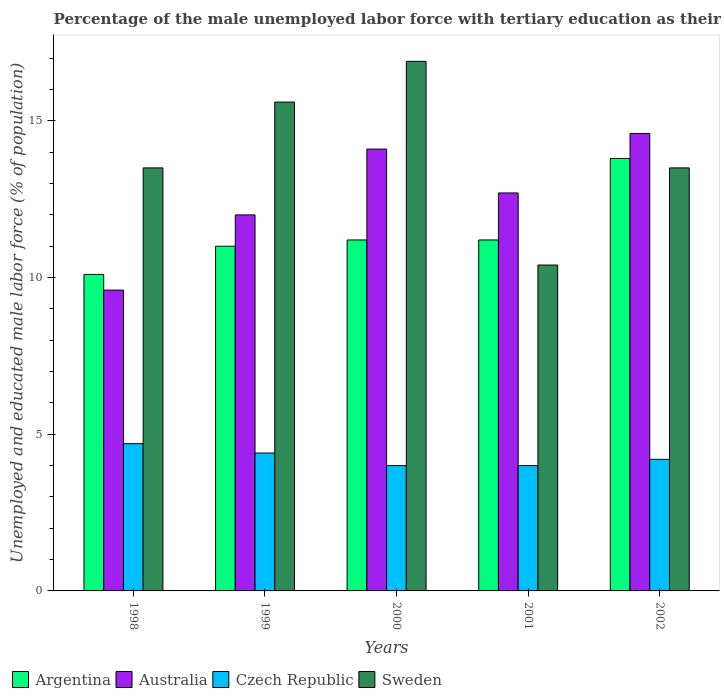How many different coloured bars are there?
Your response must be concise. 4. How many groups of bars are there?
Provide a short and direct response. 5. Are the number of bars per tick equal to the number of legend labels?
Offer a very short reply. Yes. Are the number of bars on each tick of the X-axis equal?
Offer a terse response. Yes. How many bars are there on the 1st tick from the right?
Provide a short and direct response. 4. What is the label of the 5th group of bars from the left?
Your answer should be very brief. 2002. What is the percentage of the unemployed male labor force with tertiary education in Argentina in 2002?
Keep it short and to the point. 13.8. Across all years, what is the maximum percentage of the unemployed male labor force with tertiary education in Australia?
Your response must be concise. 14.6. Across all years, what is the minimum percentage of the unemployed male labor force with tertiary education in Czech Republic?
Your response must be concise. 4. In which year was the percentage of the unemployed male labor force with tertiary education in Australia maximum?
Ensure brevity in your answer.  2002. What is the total percentage of the unemployed male labor force with tertiary education in Czech Republic in the graph?
Offer a terse response. 21.3. What is the difference between the percentage of the unemployed male labor force with tertiary education in Australia in 1998 and that in 2002?
Provide a succinct answer. -5. What is the difference between the percentage of the unemployed male labor force with tertiary education in Argentina in 2001 and the percentage of the unemployed male labor force with tertiary education in Australia in 1999?
Offer a very short reply. -0.8. What is the average percentage of the unemployed male labor force with tertiary education in Argentina per year?
Your answer should be very brief. 11.46. In the year 2002, what is the difference between the percentage of the unemployed male labor force with tertiary education in Czech Republic and percentage of the unemployed male labor force with tertiary education in Sweden?
Give a very brief answer. -9.3. In how many years, is the percentage of the unemployed male labor force with tertiary education in Sweden greater than 5 %?
Keep it short and to the point. 5. What is the ratio of the percentage of the unemployed male labor force with tertiary education in Czech Republic in 1999 to that in 2002?
Offer a very short reply. 1.05. Is the percentage of the unemployed male labor force with tertiary education in Czech Republic in 1998 less than that in 1999?
Provide a succinct answer. No. Is the difference between the percentage of the unemployed male labor force with tertiary education in Czech Republic in 2000 and 2001 greater than the difference between the percentage of the unemployed male labor force with tertiary education in Sweden in 2000 and 2001?
Offer a terse response. No. What is the difference between the highest and the second highest percentage of the unemployed male labor force with tertiary education in Czech Republic?
Your response must be concise. 0.3. What is the difference between the highest and the lowest percentage of the unemployed male labor force with tertiary education in Australia?
Give a very brief answer. 5. In how many years, is the percentage of the unemployed male labor force with tertiary education in Australia greater than the average percentage of the unemployed male labor force with tertiary education in Australia taken over all years?
Your answer should be very brief. 3. What does the 3rd bar from the left in 2002 represents?
Your response must be concise. Czech Republic. Is it the case that in every year, the sum of the percentage of the unemployed male labor force with tertiary education in Czech Republic and percentage of the unemployed male labor force with tertiary education in Sweden is greater than the percentage of the unemployed male labor force with tertiary education in Argentina?
Make the answer very short. Yes. How many bars are there?
Your answer should be very brief. 20. How many years are there in the graph?
Your answer should be compact. 5. Are the values on the major ticks of Y-axis written in scientific E-notation?
Ensure brevity in your answer.  No. Does the graph contain any zero values?
Your answer should be compact. No. Where does the legend appear in the graph?
Offer a terse response. Bottom left. What is the title of the graph?
Offer a very short reply. Percentage of the male unemployed labor force with tertiary education as their highest grade. Does "St. Lucia" appear as one of the legend labels in the graph?
Give a very brief answer. No. What is the label or title of the Y-axis?
Your response must be concise. Unemployed and educated male labor force (% of population). What is the Unemployed and educated male labor force (% of population) of Argentina in 1998?
Offer a very short reply. 10.1. What is the Unemployed and educated male labor force (% of population) in Australia in 1998?
Offer a very short reply. 9.6. What is the Unemployed and educated male labor force (% of population) of Czech Republic in 1998?
Ensure brevity in your answer.  4.7. What is the Unemployed and educated male labor force (% of population) of Sweden in 1998?
Ensure brevity in your answer.  13.5. What is the Unemployed and educated male labor force (% of population) of Argentina in 1999?
Your response must be concise. 11. What is the Unemployed and educated male labor force (% of population) of Australia in 1999?
Keep it short and to the point. 12. What is the Unemployed and educated male labor force (% of population) of Czech Republic in 1999?
Make the answer very short. 4.4. What is the Unemployed and educated male labor force (% of population) of Sweden in 1999?
Ensure brevity in your answer.  15.6. What is the Unemployed and educated male labor force (% of population) of Argentina in 2000?
Give a very brief answer. 11.2. What is the Unemployed and educated male labor force (% of population) in Australia in 2000?
Offer a terse response. 14.1. What is the Unemployed and educated male labor force (% of population) in Czech Republic in 2000?
Your response must be concise. 4. What is the Unemployed and educated male labor force (% of population) of Sweden in 2000?
Your answer should be very brief. 16.9. What is the Unemployed and educated male labor force (% of population) in Argentina in 2001?
Provide a succinct answer. 11.2. What is the Unemployed and educated male labor force (% of population) of Australia in 2001?
Ensure brevity in your answer.  12.7. What is the Unemployed and educated male labor force (% of population) of Czech Republic in 2001?
Your response must be concise. 4. What is the Unemployed and educated male labor force (% of population) in Sweden in 2001?
Your answer should be very brief. 10.4. What is the Unemployed and educated male labor force (% of population) in Argentina in 2002?
Provide a short and direct response. 13.8. What is the Unemployed and educated male labor force (% of population) in Australia in 2002?
Give a very brief answer. 14.6. What is the Unemployed and educated male labor force (% of population) in Czech Republic in 2002?
Give a very brief answer. 4.2. What is the Unemployed and educated male labor force (% of population) in Sweden in 2002?
Offer a very short reply. 13.5. Across all years, what is the maximum Unemployed and educated male labor force (% of population) in Argentina?
Provide a succinct answer. 13.8. Across all years, what is the maximum Unemployed and educated male labor force (% of population) of Australia?
Offer a terse response. 14.6. Across all years, what is the maximum Unemployed and educated male labor force (% of population) of Czech Republic?
Keep it short and to the point. 4.7. Across all years, what is the maximum Unemployed and educated male labor force (% of population) in Sweden?
Give a very brief answer. 16.9. Across all years, what is the minimum Unemployed and educated male labor force (% of population) of Argentina?
Keep it short and to the point. 10.1. Across all years, what is the minimum Unemployed and educated male labor force (% of population) in Australia?
Provide a succinct answer. 9.6. Across all years, what is the minimum Unemployed and educated male labor force (% of population) of Sweden?
Give a very brief answer. 10.4. What is the total Unemployed and educated male labor force (% of population) of Argentina in the graph?
Give a very brief answer. 57.3. What is the total Unemployed and educated male labor force (% of population) in Czech Republic in the graph?
Your answer should be very brief. 21.3. What is the total Unemployed and educated male labor force (% of population) of Sweden in the graph?
Your response must be concise. 69.9. What is the difference between the Unemployed and educated male labor force (% of population) in Argentina in 1998 and that in 1999?
Offer a terse response. -0.9. What is the difference between the Unemployed and educated male labor force (% of population) of Australia in 1998 and that in 1999?
Offer a terse response. -2.4. What is the difference between the Unemployed and educated male labor force (% of population) of Sweden in 1998 and that in 1999?
Ensure brevity in your answer.  -2.1. What is the difference between the Unemployed and educated male labor force (% of population) in Australia in 1998 and that in 2000?
Keep it short and to the point. -4.5. What is the difference between the Unemployed and educated male labor force (% of population) of Czech Republic in 1998 and that in 2000?
Make the answer very short. 0.7. What is the difference between the Unemployed and educated male labor force (% of population) of Sweden in 1998 and that in 2000?
Keep it short and to the point. -3.4. What is the difference between the Unemployed and educated male labor force (% of population) in Argentina in 1998 and that in 2001?
Keep it short and to the point. -1.1. What is the difference between the Unemployed and educated male labor force (% of population) of Sweden in 1998 and that in 2001?
Give a very brief answer. 3.1. What is the difference between the Unemployed and educated male labor force (% of population) of Argentina in 1998 and that in 2002?
Make the answer very short. -3.7. What is the difference between the Unemployed and educated male labor force (% of population) of Czech Republic in 1998 and that in 2002?
Ensure brevity in your answer.  0.5. What is the difference between the Unemployed and educated male labor force (% of population) of Sweden in 1998 and that in 2002?
Keep it short and to the point. 0. What is the difference between the Unemployed and educated male labor force (% of population) of Czech Republic in 1999 and that in 2000?
Offer a terse response. 0.4. What is the difference between the Unemployed and educated male labor force (% of population) in Sweden in 1999 and that in 2000?
Offer a very short reply. -1.3. What is the difference between the Unemployed and educated male labor force (% of population) in Argentina in 1999 and that in 2001?
Keep it short and to the point. -0.2. What is the difference between the Unemployed and educated male labor force (% of population) of Australia in 1999 and that in 2001?
Your answer should be compact. -0.7. What is the difference between the Unemployed and educated male labor force (% of population) of Czech Republic in 1999 and that in 2001?
Offer a terse response. 0.4. What is the difference between the Unemployed and educated male labor force (% of population) of Argentina in 1999 and that in 2002?
Your answer should be compact. -2.8. What is the difference between the Unemployed and educated male labor force (% of population) of Argentina in 2000 and that in 2001?
Your answer should be compact. 0. What is the difference between the Unemployed and educated male labor force (% of population) in Sweden in 2000 and that in 2001?
Give a very brief answer. 6.5. What is the difference between the Unemployed and educated male labor force (% of population) of Argentina in 2000 and that in 2002?
Provide a short and direct response. -2.6. What is the difference between the Unemployed and educated male labor force (% of population) of Argentina in 2001 and that in 2002?
Provide a succinct answer. -2.6. What is the difference between the Unemployed and educated male labor force (% of population) of Sweden in 2001 and that in 2002?
Give a very brief answer. -3.1. What is the difference between the Unemployed and educated male labor force (% of population) of Argentina in 1998 and the Unemployed and educated male labor force (% of population) of Australia in 1999?
Ensure brevity in your answer.  -1.9. What is the difference between the Unemployed and educated male labor force (% of population) of Argentina in 1998 and the Unemployed and educated male labor force (% of population) of Czech Republic in 1999?
Your answer should be compact. 5.7. What is the difference between the Unemployed and educated male labor force (% of population) in Australia in 1998 and the Unemployed and educated male labor force (% of population) in Czech Republic in 1999?
Make the answer very short. 5.2. What is the difference between the Unemployed and educated male labor force (% of population) of Australia in 1998 and the Unemployed and educated male labor force (% of population) of Sweden in 1999?
Your response must be concise. -6. What is the difference between the Unemployed and educated male labor force (% of population) in Argentina in 1998 and the Unemployed and educated male labor force (% of population) in Australia in 2000?
Provide a succinct answer. -4. What is the difference between the Unemployed and educated male labor force (% of population) of Czech Republic in 1998 and the Unemployed and educated male labor force (% of population) of Sweden in 2000?
Offer a very short reply. -12.2. What is the difference between the Unemployed and educated male labor force (% of population) of Argentina in 1998 and the Unemployed and educated male labor force (% of population) of Czech Republic in 2001?
Provide a succinct answer. 6.1. What is the difference between the Unemployed and educated male labor force (% of population) in Argentina in 1998 and the Unemployed and educated male labor force (% of population) in Sweden in 2001?
Keep it short and to the point. -0.3. What is the difference between the Unemployed and educated male labor force (% of population) of Czech Republic in 1998 and the Unemployed and educated male labor force (% of population) of Sweden in 2001?
Make the answer very short. -5.7. What is the difference between the Unemployed and educated male labor force (% of population) in Czech Republic in 1998 and the Unemployed and educated male labor force (% of population) in Sweden in 2002?
Ensure brevity in your answer.  -8.8. What is the difference between the Unemployed and educated male labor force (% of population) in Argentina in 1999 and the Unemployed and educated male labor force (% of population) in Australia in 2000?
Your answer should be compact. -3.1. What is the difference between the Unemployed and educated male labor force (% of population) in Argentina in 1999 and the Unemployed and educated male labor force (% of population) in Sweden in 2000?
Ensure brevity in your answer.  -5.9. What is the difference between the Unemployed and educated male labor force (% of population) in Australia in 1999 and the Unemployed and educated male labor force (% of population) in Sweden in 2000?
Your response must be concise. -4.9. What is the difference between the Unemployed and educated male labor force (% of population) in Czech Republic in 1999 and the Unemployed and educated male labor force (% of population) in Sweden in 2000?
Offer a very short reply. -12.5. What is the difference between the Unemployed and educated male labor force (% of population) in Argentina in 1999 and the Unemployed and educated male labor force (% of population) in Sweden in 2001?
Offer a terse response. 0.6. What is the difference between the Unemployed and educated male labor force (% of population) in Australia in 1999 and the Unemployed and educated male labor force (% of population) in Czech Republic in 2001?
Provide a succinct answer. 8. What is the difference between the Unemployed and educated male labor force (% of population) of Australia in 1999 and the Unemployed and educated male labor force (% of population) of Sweden in 2001?
Ensure brevity in your answer.  1.6. What is the difference between the Unemployed and educated male labor force (% of population) of Czech Republic in 1999 and the Unemployed and educated male labor force (% of population) of Sweden in 2001?
Give a very brief answer. -6. What is the difference between the Unemployed and educated male labor force (% of population) of Argentina in 1999 and the Unemployed and educated male labor force (% of population) of Australia in 2002?
Offer a terse response. -3.6. What is the difference between the Unemployed and educated male labor force (% of population) in Argentina in 2000 and the Unemployed and educated male labor force (% of population) in Australia in 2001?
Keep it short and to the point. -1.5. What is the difference between the Unemployed and educated male labor force (% of population) in Australia in 2000 and the Unemployed and educated male labor force (% of population) in Sweden in 2001?
Keep it short and to the point. 3.7. What is the difference between the Unemployed and educated male labor force (% of population) in Czech Republic in 2000 and the Unemployed and educated male labor force (% of population) in Sweden in 2001?
Give a very brief answer. -6.4. What is the difference between the Unemployed and educated male labor force (% of population) in Argentina in 2000 and the Unemployed and educated male labor force (% of population) in Sweden in 2002?
Your answer should be compact. -2.3. What is the difference between the Unemployed and educated male labor force (% of population) in Australia in 2000 and the Unemployed and educated male labor force (% of population) in Czech Republic in 2002?
Ensure brevity in your answer.  9.9. What is the difference between the Unemployed and educated male labor force (% of population) of Argentina in 2001 and the Unemployed and educated male labor force (% of population) of Czech Republic in 2002?
Your answer should be very brief. 7. What is the difference between the Unemployed and educated male labor force (% of population) of Australia in 2001 and the Unemployed and educated male labor force (% of population) of Czech Republic in 2002?
Make the answer very short. 8.5. What is the difference between the Unemployed and educated male labor force (% of population) of Czech Republic in 2001 and the Unemployed and educated male labor force (% of population) of Sweden in 2002?
Your answer should be compact. -9.5. What is the average Unemployed and educated male labor force (% of population) in Argentina per year?
Your response must be concise. 11.46. What is the average Unemployed and educated male labor force (% of population) of Australia per year?
Your answer should be compact. 12.6. What is the average Unemployed and educated male labor force (% of population) of Czech Republic per year?
Offer a very short reply. 4.26. What is the average Unemployed and educated male labor force (% of population) in Sweden per year?
Keep it short and to the point. 13.98. In the year 1998, what is the difference between the Unemployed and educated male labor force (% of population) of Argentina and Unemployed and educated male labor force (% of population) of Czech Republic?
Make the answer very short. 5.4. In the year 1998, what is the difference between the Unemployed and educated male labor force (% of population) of Argentina and Unemployed and educated male labor force (% of population) of Sweden?
Offer a terse response. -3.4. In the year 1998, what is the difference between the Unemployed and educated male labor force (% of population) in Czech Republic and Unemployed and educated male labor force (% of population) in Sweden?
Keep it short and to the point. -8.8. In the year 1999, what is the difference between the Unemployed and educated male labor force (% of population) of Argentina and Unemployed and educated male labor force (% of population) of Australia?
Provide a short and direct response. -1. In the year 1999, what is the difference between the Unemployed and educated male labor force (% of population) of Argentina and Unemployed and educated male labor force (% of population) of Czech Republic?
Provide a succinct answer. 6.6. In the year 1999, what is the difference between the Unemployed and educated male labor force (% of population) in Australia and Unemployed and educated male labor force (% of population) in Sweden?
Make the answer very short. -3.6. In the year 2000, what is the difference between the Unemployed and educated male labor force (% of population) in Czech Republic and Unemployed and educated male labor force (% of population) in Sweden?
Provide a short and direct response. -12.9. In the year 2001, what is the difference between the Unemployed and educated male labor force (% of population) of Argentina and Unemployed and educated male labor force (% of population) of Australia?
Provide a short and direct response. -1.5. In the year 2001, what is the difference between the Unemployed and educated male labor force (% of population) in Argentina and Unemployed and educated male labor force (% of population) in Czech Republic?
Offer a very short reply. 7.2. In the year 2001, what is the difference between the Unemployed and educated male labor force (% of population) in Australia and Unemployed and educated male labor force (% of population) in Czech Republic?
Provide a short and direct response. 8.7. In the year 2001, what is the difference between the Unemployed and educated male labor force (% of population) of Australia and Unemployed and educated male labor force (% of population) of Sweden?
Offer a very short reply. 2.3. In the year 2002, what is the difference between the Unemployed and educated male labor force (% of population) in Argentina and Unemployed and educated male labor force (% of population) in Sweden?
Offer a very short reply. 0.3. What is the ratio of the Unemployed and educated male labor force (% of population) in Argentina in 1998 to that in 1999?
Provide a succinct answer. 0.92. What is the ratio of the Unemployed and educated male labor force (% of population) in Czech Republic in 1998 to that in 1999?
Ensure brevity in your answer.  1.07. What is the ratio of the Unemployed and educated male labor force (% of population) of Sweden in 1998 to that in 1999?
Your response must be concise. 0.87. What is the ratio of the Unemployed and educated male labor force (% of population) of Argentina in 1998 to that in 2000?
Make the answer very short. 0.9. What is the ratio of the Unemployed and educated male labor force (% of population) of Australia in 1998 to that in 2000?
Make the answer very short. 0.68. What is the ratio of the Unemployed and educated male labor force (% of population) in Czech Republic in 1998 to that in 2000?
Offer a very short reply. 1.18. What is the ratio of the Unemployed and educated male labor force (% of population) of Sweden in 1998 to that in 2000?
Provide a succinct answer. 0.8. What is the ratio of the Unemployed and educated male labor force (% of population) in Argentina in 1998 to that in 2001?
Your answer should be very brief. 0.9. What is the ratio of the Unemployed and educated male labor force (% of population) of Australia in 1998 to that in 2001?
Provide a succinct answer. 0.76. What is the ratio of the Unemployed and educated male labor force (% of population) in Czech Republic in 1998 to that in 2001?
Ensure brevity in your answer.  1.18. What is the ratio of the Unemployed and educated male labor force (% of population) of Sweden in 1998 to that in 2001?
Ensure brevity in your answer.  1.3. What is the ratio of the Unemployed and educated male labor force (% of population) of Argentina in 1998 to that in 2002?
Make the answer very short. 0.73. What is the ratio of the Unemployed and educated male labor force (% of population) in Australia in 1998 to that in 2002?
Your answer should be very brief. 0.66. What is the ratio of the Unemployed and educated male labor force (% of population) of Czech Republic in 1998 to that in 2002?
Keep it short and to the point. 1.12. What is the ratio of the Unemployed and educated male labor force (% of population) in Sweden in 1998 to that in 2002?
Make the answer very short. 1. What is the ratio of the Unemployed and educated male labor force (% of population) of Argentina in 1999 to that in 2000?
Your answer should be very brief. 0.98. What is the ratio of the Unemployed and educated male labor force (% of population) in Australia in 1999 to that in 2000?
Ensure brevity in your answer.  0.85. What is the ratio of the Unemployed and educated male labor force (% of population) in Czech Republic in 1999 to that in 2000?
Your answer should be very brief. 1.1. What is the ratio of the Unemployed and educated male labor force (% of population) in Argentina in 1999 to that in 2001?
Your answer should be compact. 0.98. What is the ratio of the Unemployed and educated male labor force (% of population) of Australia in 1999 to that in 2001?
Offer a very short reply. 0.94. What is the ratio of the Unemployed and educated male labor force (% of population) of Czech Republic in 1999 to that in 2001?
Give a very brief answer. 1.1. What is the ratio of the Unemployed and educated male labor force (% of population) of Sweden in 1999 to that in 2001?
Your response must be concise. 1.5. What is the ratio of the Unemployed and educated male labor force (% of population) in Argentina in 1999 to that in 2002?
Your response must be concise. 0.8. What is the ratio of the Unemployed and educated male labor force (% of population) of Australia in 1999 to that in 2002?
Keep it short and to the point. 0.82. What is the ratio of the Unemployed and educated male labor force (% of population) of Czech Republic in 1999 to that in 2002?
Provide a short and direct response. 1.05. What is the ratio of the Unemployed and educated male labor force (% of population) of Sweden in 1999 to that in 2002?
Give a very brief answer. 1.16. What is the ratio of the Unemployed and educated male labor force (% of population) in Australia in 2000 to that in 2001?
Your answer should be compact. 1.11. What is the ratio of the Unemployed and educated male labor force (% of population) in Sweden in 2000 to that in 2001?
Your response must be concise. 1.62. What is the ratio of the Unemployed and educated male labor force (% of population) of Argentina in 2000 to that in 2002?
Give a very brief answer. 0.81. What is the ratio of the Unemployed and educated male labor force (% of population) of Australia in 2000 to that in 2002?
Offer a very short reply. 0.97. What is the ratio of the Unemployed and educated male labor force (% of population) of Sweden in 2000 to that in 2002?
Give a very brief answer. 1.25. What is the ratio of the Unemployed and educated male labor force (% of population) of Argentina in 2001 to that in 2002?
Make the answer very short. 0.81. What is the ratio of the Unemployed and educated male labor force (% of population) in Australia in 2001 to that in 2002?
Your response must be concise. 0.87. What is the ratio of the Unemployed and educated male labor force (% of population) in Czech Republic in 2001 to that in 2002?
Provide a short and direct response. 0.95. What is the ratio of the Unemployed and educated male labor force (% of population) of Sweden in 2001 to that in 2002?
Keep it short and to the point. 0.77. What is the difference between the highest and the second highest Unemployed and educated male labor force (% of population) in Sweden?
Provide a short and direct response. 1.3. What is the difference between the highest and the lowest Unemployed and educated male labor force (% of population) of Argentina?
Offer a very short reply. 3.7. What is the difference between the highest and the lowest Unemployed and educated male labor force (% of population) in Australia?
Your answer should be very brief. 5. 